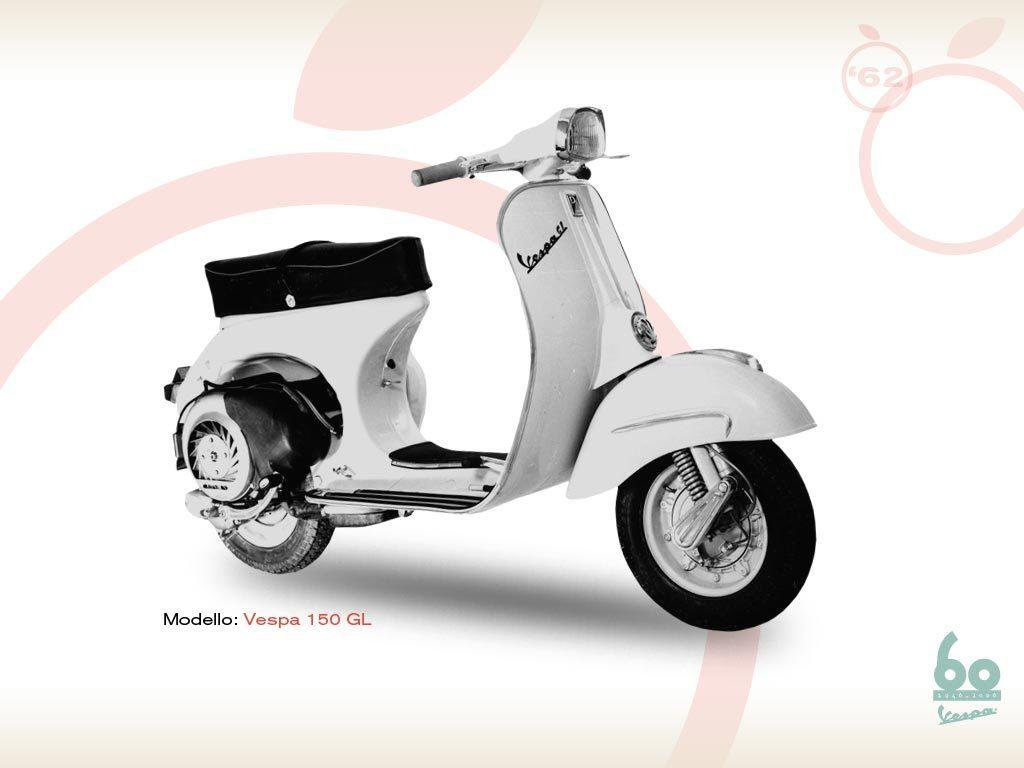What is the main object in the image? There is a scooter in the image. What else can be seen on the image besides the scooter? There is text and a design in the background of the image. Where are the numbers and text located in the image? They are in the bottom right of the image. What type of knot is being tied by the father in the image? There is no father or knot present in the image; it features a scooter with text and a design in the background. 